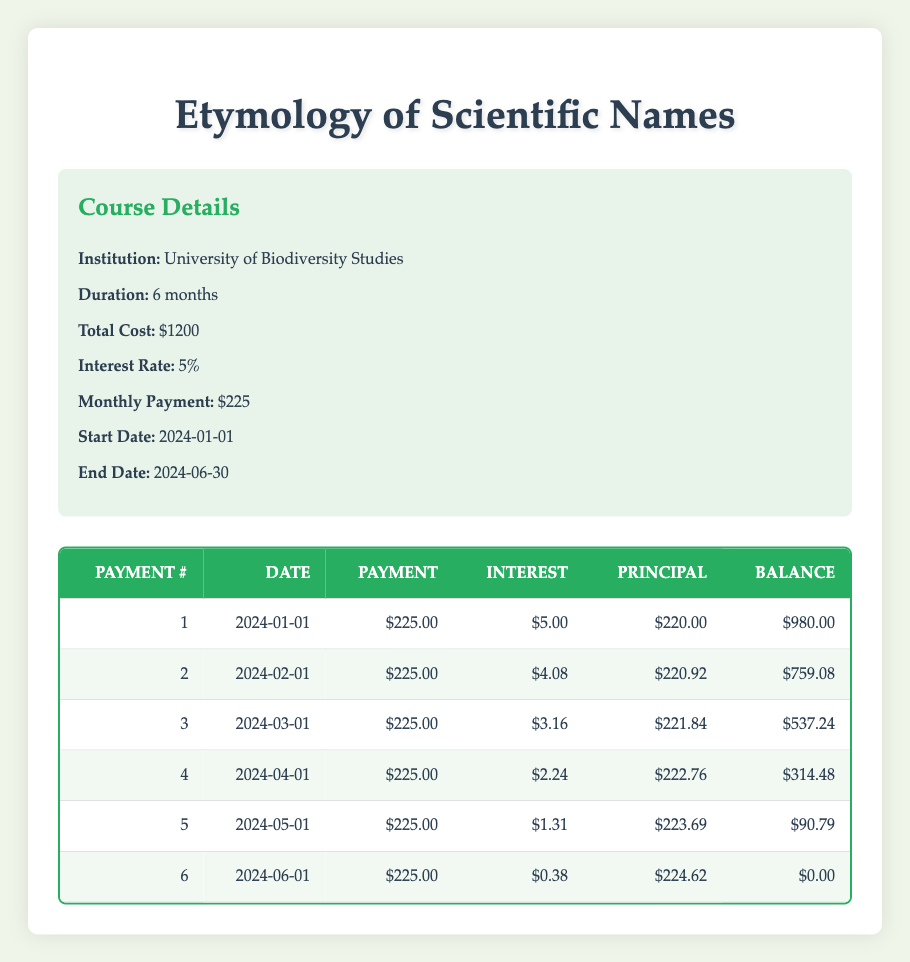What is the total cost of the course? The total cost is provided directly in the course details section of the table, which states the total cost is 1200.
Answer: 1200 What was the remaining balance after the 4th payment? To find the remaining balance after the 4th payment, we look at the "Remaining Balance" column for payment number 4, which shows 314.48.
Answer: 314.48 How much interest was paid in the 2nd payment? The interest paid for the 2nd payment is listed in the table under the "Interest" column for payment number 2, which is 4.08.
Answer: 4.08 What is the total principal paid after 6 payments? The total principal paid is the sum of the "Principal" amounts from all six payments. Adding them up: 220 + 220.92 + 221.84 + 222.76 + 223.69 + 224.62 = 1333.84.
Answer: 1333.84 Was the interest paid in the 6th payment less than 1 dollar? In the table, the interest paid for the 6th payment is 0.38, which is indeed less than 1 dollar.
Answer: Yes What was the average monthly payment amount? The average monthly payment can be calculated by taking the total cost and dividing it by the course duration in months: 1200 / 6 = 200. However, the regular payment made is 225. The average remains 225.
Answer: 225 Which month had the highest principal paid? Looking through the principal amounts in the table, the highest principal payment is seen in the 6th payment where it is 224.62.
Answer: 6th payment What is the difference between the interest paid in the first and last payments? The interest paid in the first payment is 5 and in the last payment (6th payment), it is 0.38. Therefore, the difference is 5 - 0.38 = 4.62.
Answer: 4.62 How much remains to be paid after the 5th payment? The "Remaining Balance" after the 5th payment can be found in the table, under payment number 5, which shows a remaining balance of 90.79.
Answer: 90.79 